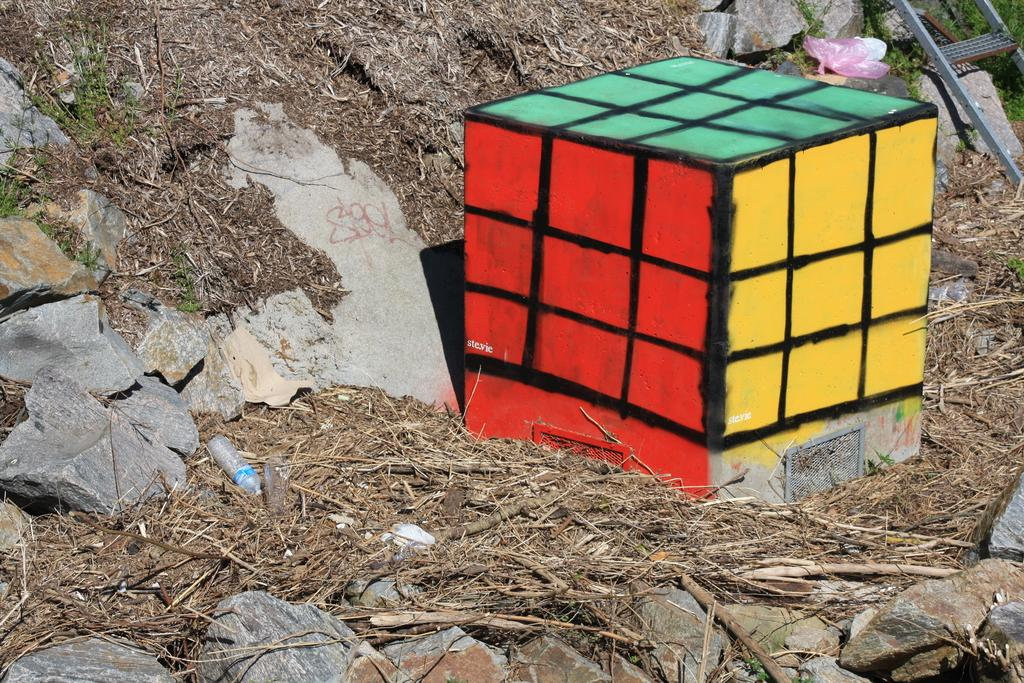What is the main subject of the image? There is a colorful puzzle in the image. Where is the puzzle located? The puzzle is placed on grass. What else can be seen on the grass in the image? Stones are visible on the grass. What type of substance is being used to play basketball in the image? There is no basketball or any substance related to basketball present in the image. 